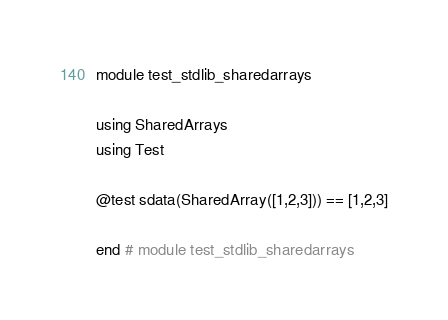Convert code to text. <code><loc_0><loc_0><loc_500><loc_500><_Julia_>module test_stdlib_sharedarrays

using SharedArrays
using Test

@test sdata(SharedArray([1,2,3])) == [1,2,3]

end # module test_stdlib_sharedarrays
</code> 